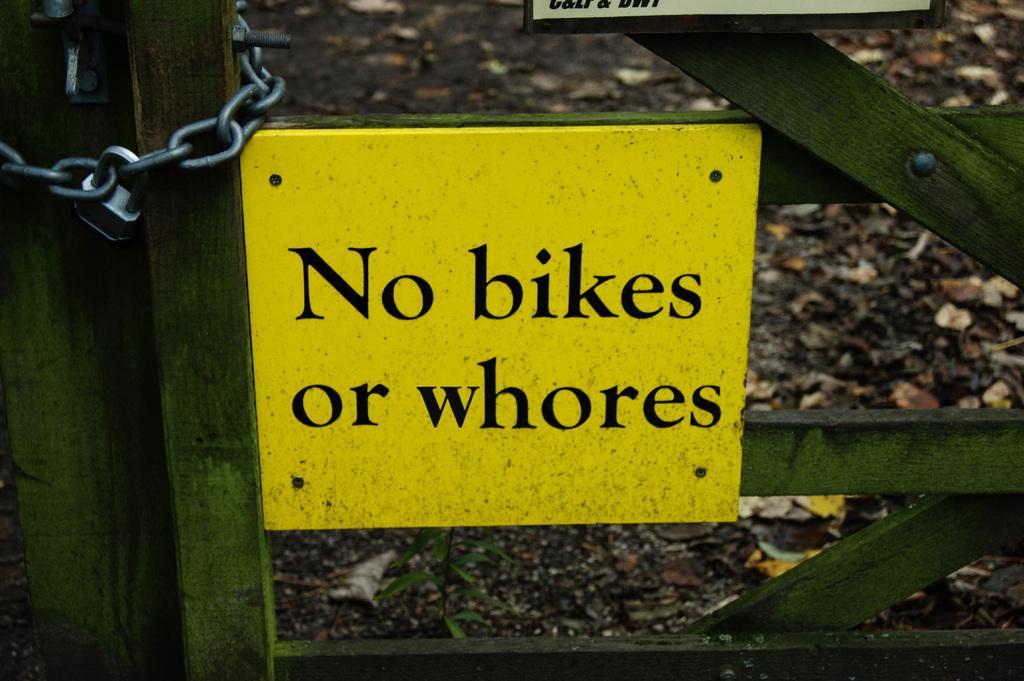Could you give a brief overview of what you see in this image? In this image, we can see a wooden fence, there is a yellow color board on the fence, we can see a chain and a lock on the left side. 